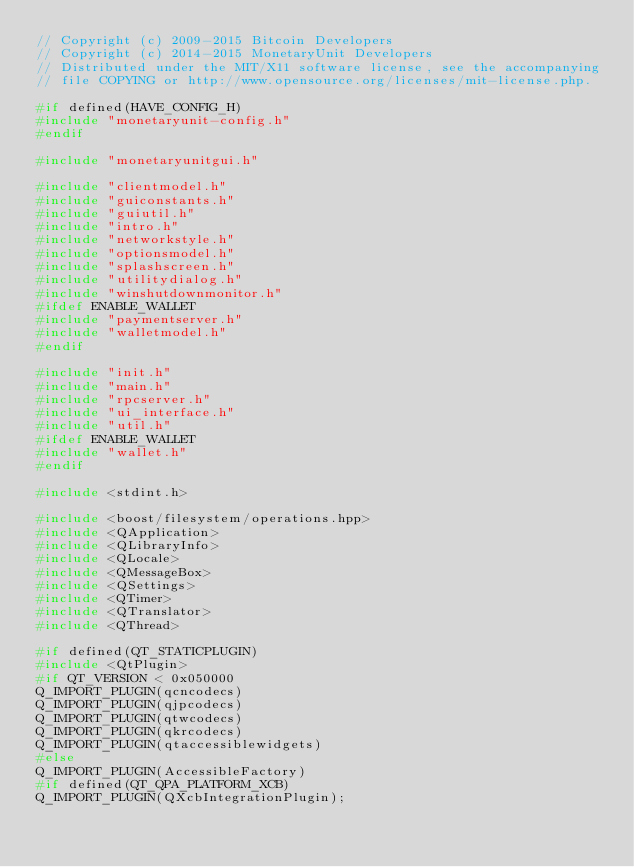<code> <loc_0><loc_0><loc_500><loc_500><_C++_>// Copyright (c) 2009-2015 Bitcoin Developers
// Copyright (c) 2014-2015 MonetaryUnit Developers
// Distributed under the MIT/X11 software license, see the accompanying
// file COPYING or http://www.opensource.org/licenses/mit-license.php.

#if defined(HAVE_CONFIG_H)
#include "monetaryunit-config.h"
#endif

#include "monetaryunitgui.h"

#include "clientmodel.h"
#include "guiconstants.h"
#include "guiutil.h"
#include "intro.h"
#include "networkstyle.h"
#include "optionsmodel.h"
#include "splashscreen.h"
#include "utilitydialog.h"
#include "winshutdownmonitor.h"
#ifdef ENABLE_WALLET
#include "paymentserver.h"
#include "walletmodel.h"
#endif

#include "init.h"
#include "main.h"
#include "rpcserver.h"
#include "ui_interface.h"
#include "util.h"
#ifdef ENABLE_WALLET
#include "wallet.h"
#endif

#include <stdint.h>

#include <boost/filesystem/operations.hpp>
#include <QApplication>
#include <QLibraryInfo>
#include <QLocale>
#include <QMessageBox>
#include <QSettings>
#include <QTimer>
#include <QTranslator>
#include <QThread>

#if defined(QT_STATICPLUGIN)
#include <QtPlugin>
#if QT_VERSION < 0x050000
Q_IMPORT_PLUGIN(qcncodecs)
Q_IMPORT_PLUGIN(qjpcodecs)
Q_IMPORT_PLUGIN(qtwcodecs)
Q_IMPORT_PLUGIN(qkrcodecs)
Q_IMPORT_PLUGIN(qtaccessiblewidgets)
#else
Q_IMPORT_PLUGIN(AccessibleFactory)
#if defined(QT_QPA_PLATFORM_XCB)
Q_IMPORT_PLUGIN(QXcbIntegrationPlugin);</code> 